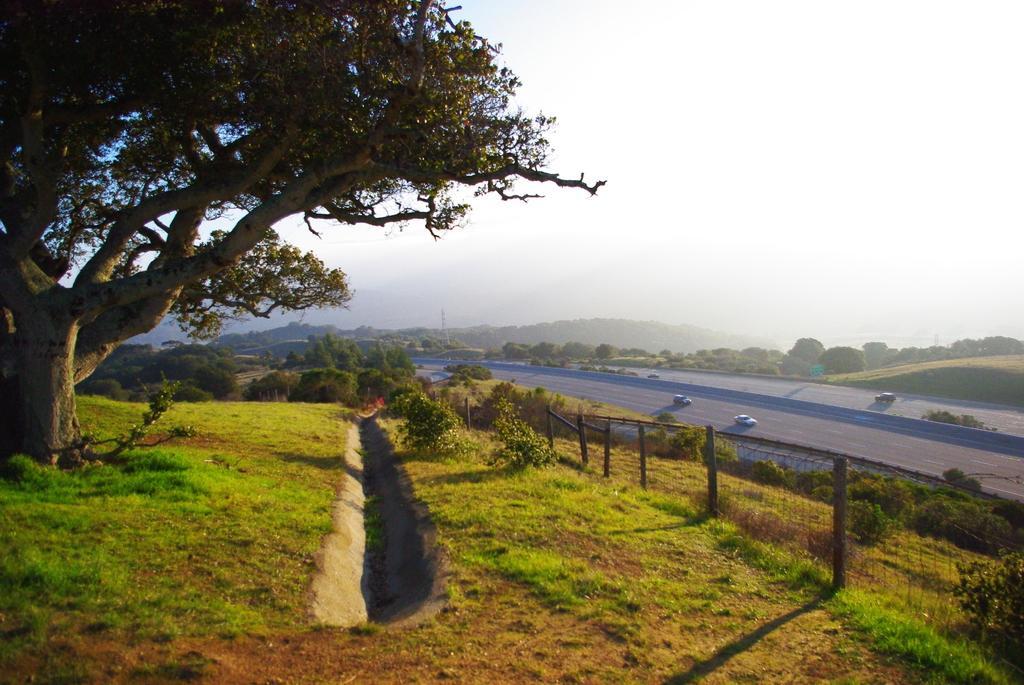Could you give a brief overview of what you see in this image? In this image I can see ground, road, grass, plants, number of trees, shadows and over there I can see few vehicles. 